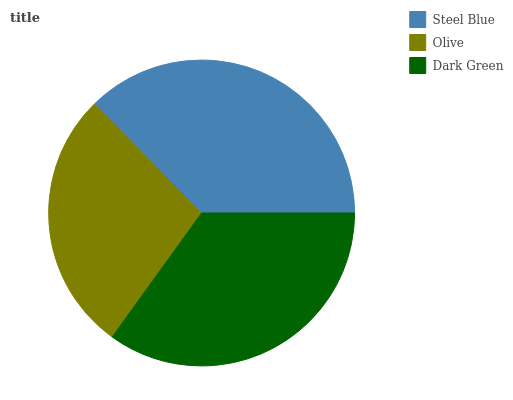Is Olive the minimum?
Answer yes or no. Yes. Is Steel Blue the maximum?
Answer yes or no. Yes. Is Dark Green the minimum?
Answer yes or no. No. Is Dark Green the maximum?
Answer yes or no. No. Is Dark Green greater than Olive?
Answer yes or no. Yes. Is Olive less than Dark Green?
Answer yes or no. Yes. Is Olive greater than Dark Green?
Answer yes or no. No. Is Dark Green less than Olive?
Answer yes or no. No. Is Dark Green the high median?
Answer yes or no. Yes. Is Dark Green the low median?
Answer yes or no. Yes. Is Olive the high median?
Answer yes or no. No. Is Olive the low median?
Answer yes or no. No. 